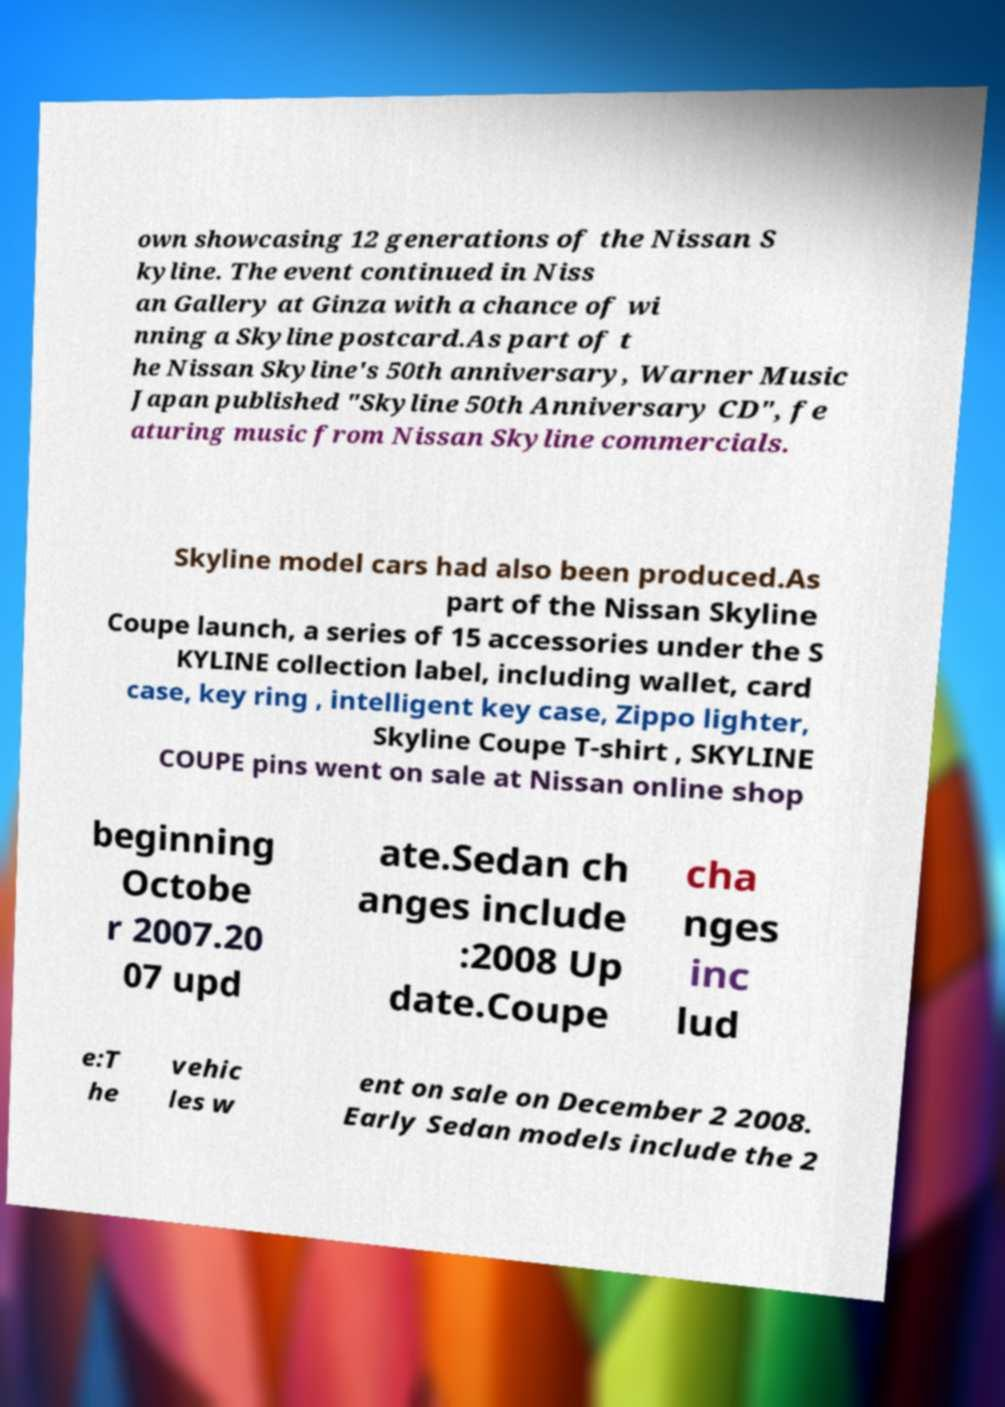What messages or text are displayed in this image? I need them in a readable, typed format. own showcasing 12 generations of the Nissan S kyline. The event continued in Niss an Gallery at Ginza with a chance of wi nning a Skyline postcard.As part of t he Nissan Skyline's 50th anniversary, Warner Music Japan published "Skyline 50th Anniversary CD", fe aturing music from Nissan Skyline commercials. Skyline model cars had also been produced.As part of the Nissan Skyline Coupe launch, a series of 15 accessories under the S KYLINE collection label, including wallet, card case, key ring , intelligent key case, Zippo lighter, Skyline Coupe T-shirt , SKYLINE COUPE pins went on sale at Nissan online shop beginning Octobe r 2007.20 07 upd ate.Sedan ch anges include :2008 Up date.Coupe cha nges inc lud e:T he vehic les w ent on sale on December 2 2008. Early Sedan models include the 2 